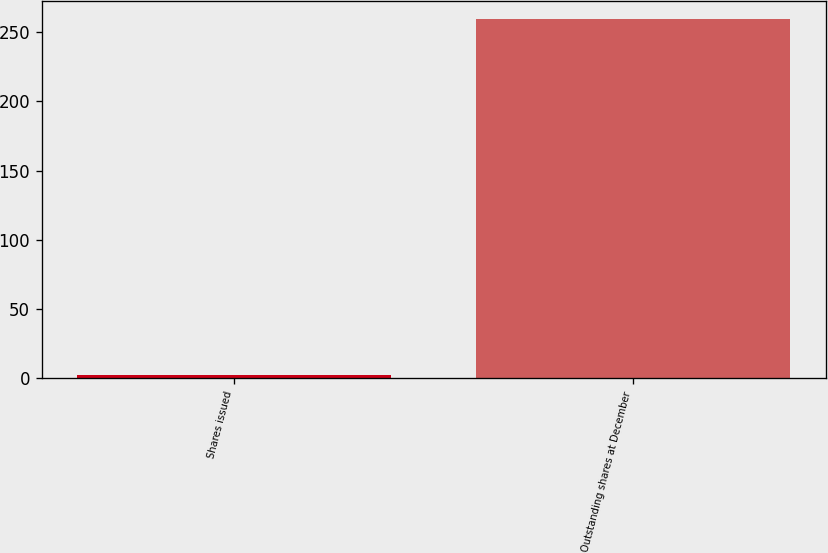Convert chart to OTSL. <chart><loc_0><loc_0><loc_500><loc_500><bar_chart><fcel>Shares issued<fcel>Outstanding shares at December<nl><fcel>2.2<fcel>259.1<nl></chart> 